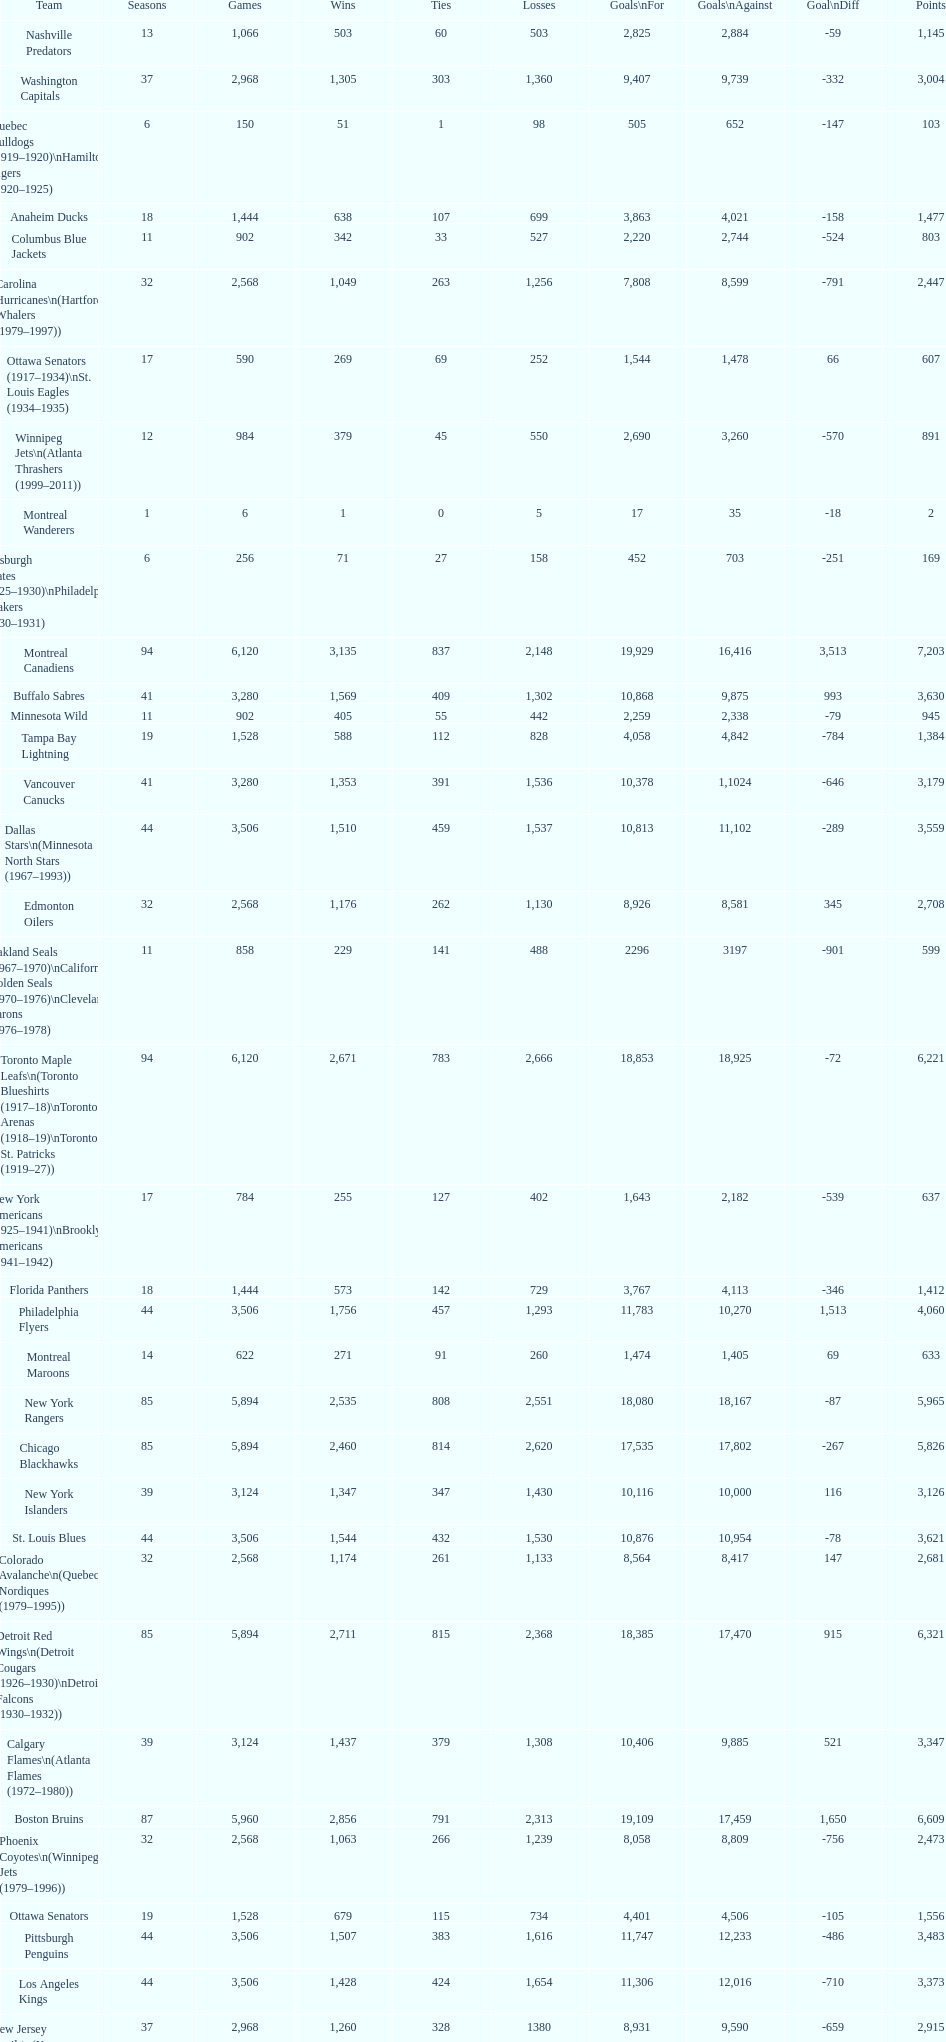How many losses do the st. louis blues have? 1,530. 